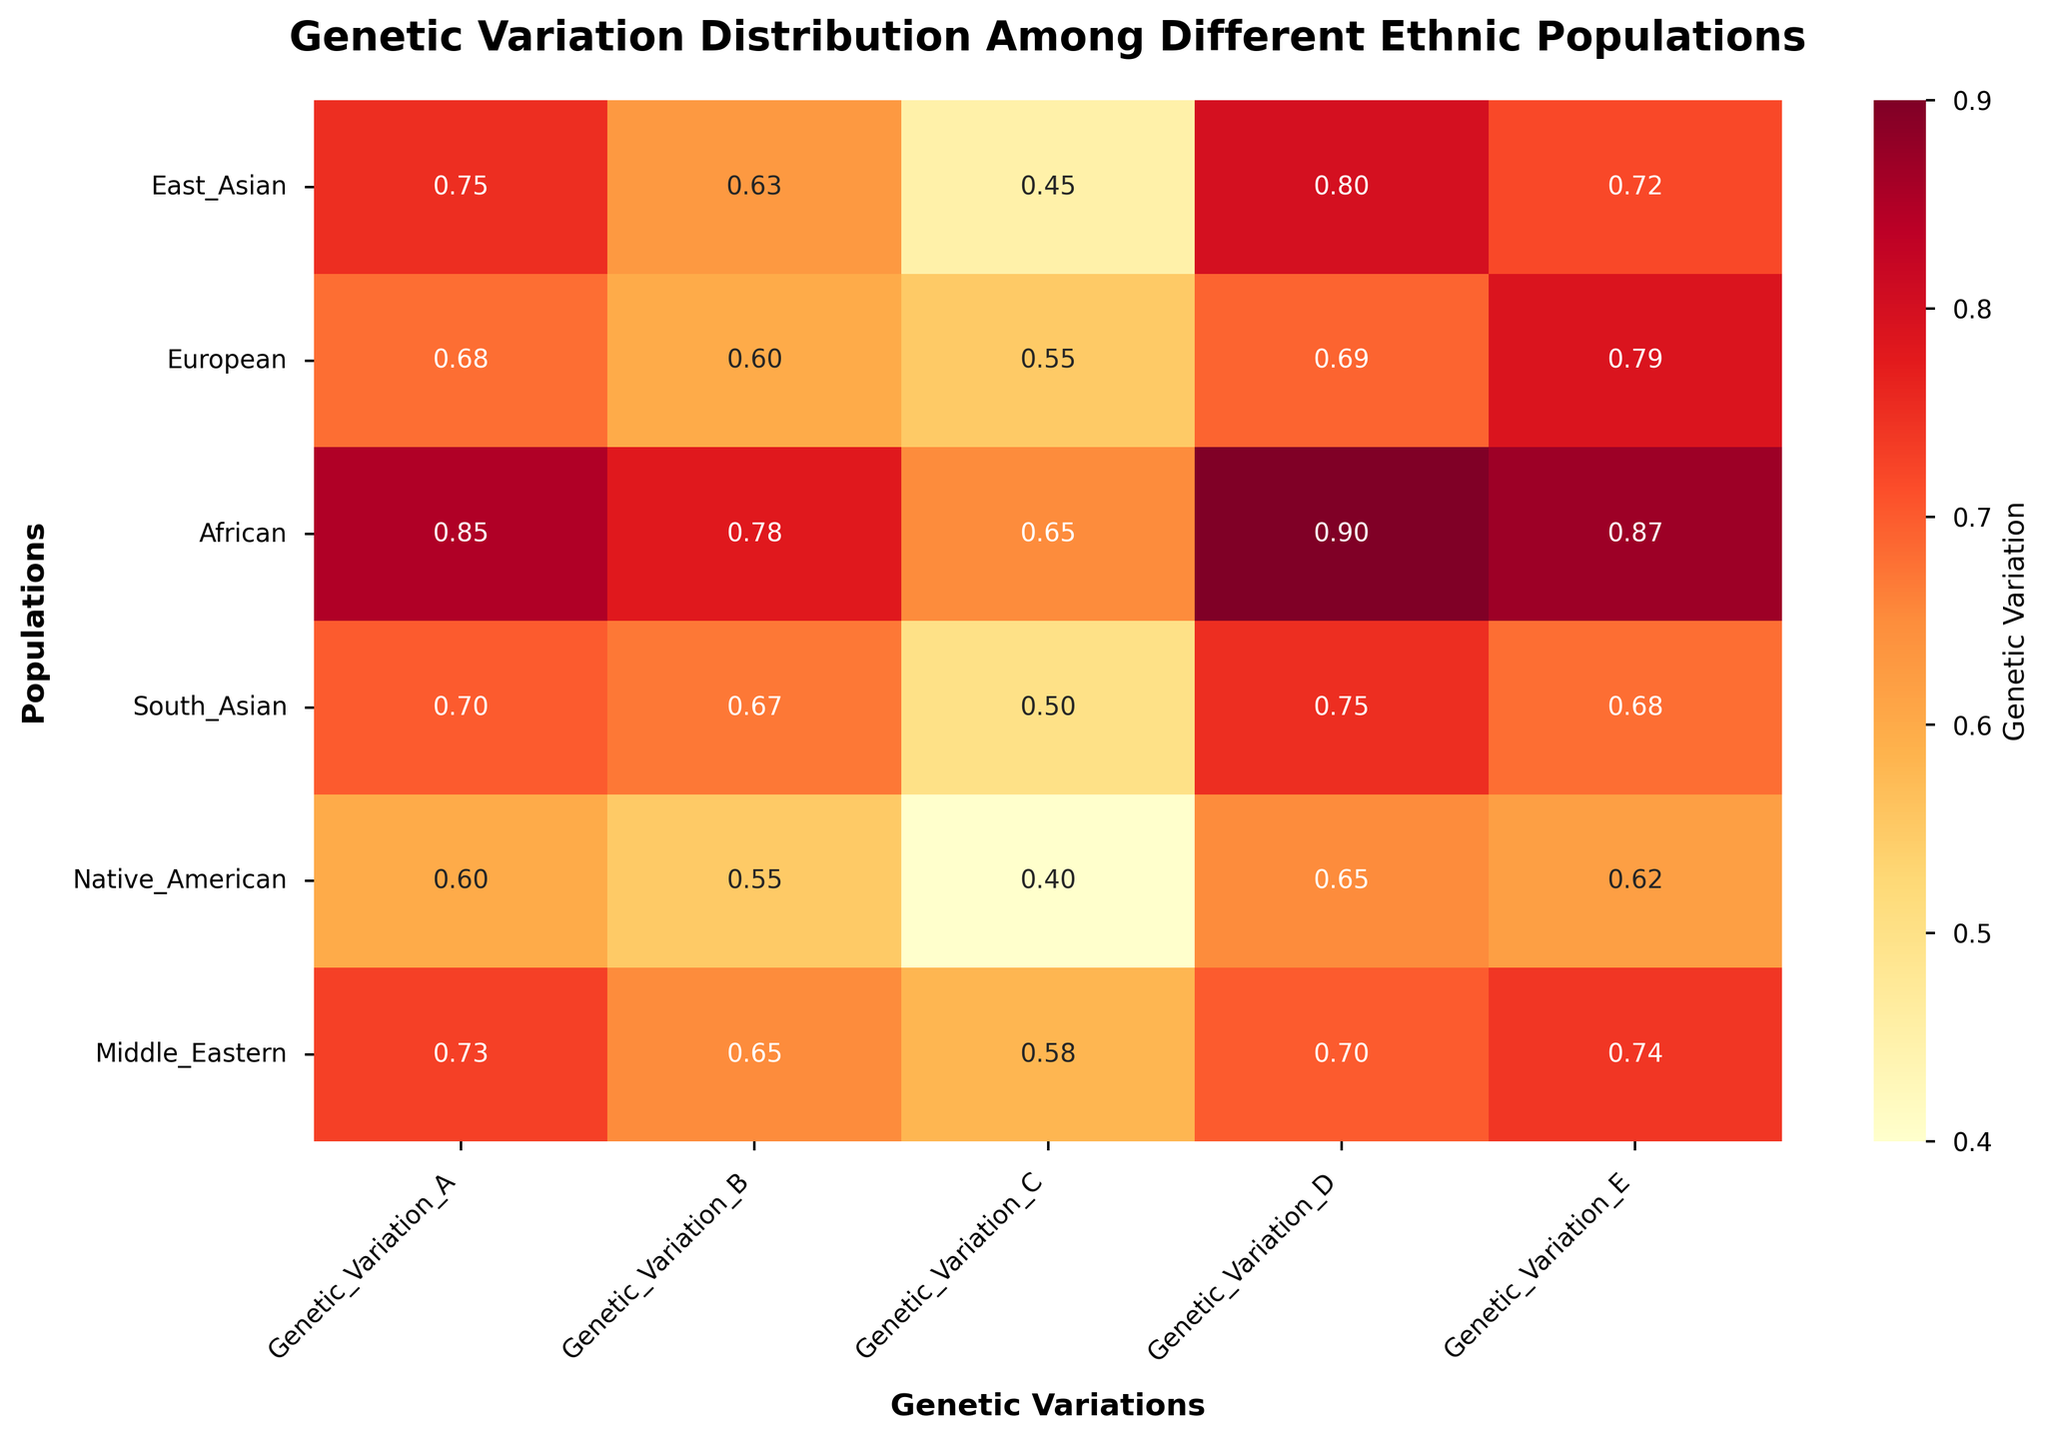What is the main title of the heatmap? The main title is located at the top of the heatmap and describes the overall subject of the figure. The title reads 'Genetic Variation Distribution Among Different Ethnic Populations'.
Answer: Genetic Variation Distribution Among Different Ethnic Populations Which population has the highest genetic variation in Variation D? To find this, locate the column for Variation D and look for the highest value in that column. The highest value is 0.90, corresponding to the African population.
Answer: African Which genetic variation has the lowest value for the Native American population? Move along the Native American row and identify the smallest value. The values are 0.60, 0.55, 0.40, 0.65, and 0.62. The smallest value is 0.40 for Genetic Variation C.
Answer: Genetic Variation C What is the average genetic variation for the East Asian population? Add up all the genetic variation values for the East Asian row (0.75, 0.63, 0.45, 0.80, 0.72) and divide by the number of values (5). (0.75 + 0.63 + 0.45 + 0.80 + 0.72) / 5 = 3.35 / 5 = 0.67
Answer: 0.67 Compare the genetic variation in Variation B between the European and African populations. Which is higher? Find the values for Genetic Variation B for both populations: European is 0.60, and African is 0.78. Since 0.78 is greater than 0.60, the African population has a higher genetic variation in Variation B.
Answer: African Which genetic variation shows the most consistent distribution across all populations (least range)? Calculate the range (max value - min value) for each genetic variation: 
- Variation A: 0.85 - 0.60 = 0.25
- Variation B: 0.78 - 0.55 = 0.23
- Variation C: 0.65 - 0.40 = 0.25
- Variation D: 0.90 - 0.65 = 0.25
- Variation E: 0.87 - 0.62 = 0.25
The smallest range is 0.23 for Genetic Variation B.
Answer: Genetic Variation B Identify the population with the most genetic variation diversity (sum of all values). Sum the values for each population and compare:
- East Asian: 0.75 + 0.63 + 0.45 + 0.80 + 0.72 = 3.35
- European: 0.68 + 0.60 + 0.55 + 0.69 + 0.79 = 3.31
- African: 0.85 + 0.78 + 0.65 + 0.90 + 0.87 = 4.05
- South Asian: 0.70 + 0.67 + 0.50 + 0.75 + 0.68 = 3.30
- Native American: 0.60 + 0.55 + 0.40 + 0.65 + 0.62 = 2.82
- Middle Eastern: 0.73 + 0.65 + 0.58 + 0.70 + 0.74 = 3.40
The African population has the highest sum with 4.05.
Answer: African What is the difference in genetic variation for Variation E between the Middle Eastern and South Asian populations? Subtract the value of Genetic Variation E in the South Asian population (0.68) from the Middle Eastern population (0.74): 0.74 - 0.68 = 0.06
Answer: 0.06 